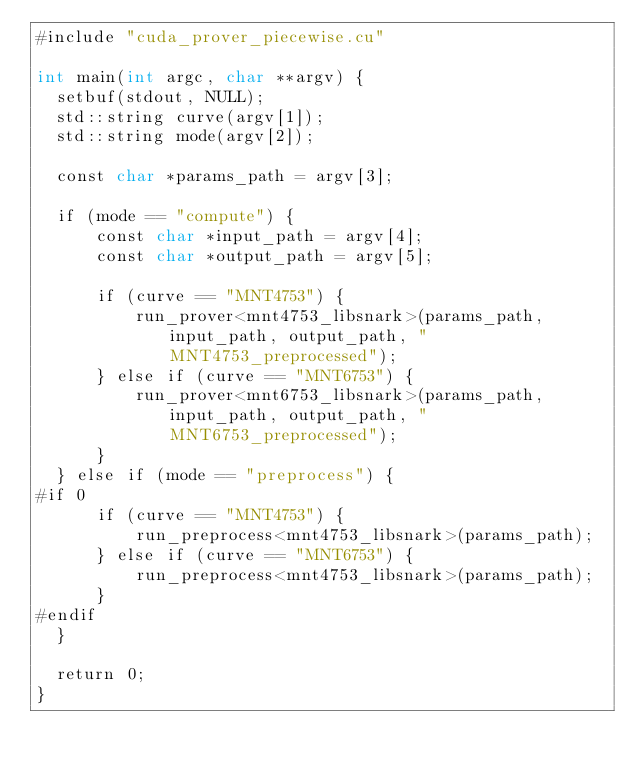Convert code to text. <code><loc_0><loc_0><loc_500><loc_500><_Cuda_>#include "cuda_prover_piecewise.cu"

int main(int argc, char **argv) {
  setbuf(stdout, NULL);
  std::string curve(argv[1]);
  std::string mode(argv[2]);

  const char *params_path = argv[3];

  if (mode == "compute") {
      const char *input_path = argv[4];
      const char *output_path = argv[5];

      if (curve == "MNT4753") {
          run_prover<mnt4753_libsnark>(params_path, input_path, output_path, "MNT4753_preprocessed");
      } else if (curve == "MNT6753") {
          run_prover<mnt6753_libsnark>(params_path, input_path, output_path, "MNT6753_preprocessed");
      }
  } else if (mode == "preprocess") {
#if 0
      if (curve == "MNT4753") {
          run_preprocess<mnt4753_libsnark>(params_path);
      } else if (curve == "MNT6753") {
          run_preprocess<mnt4753_libsnark>(params_path);
      }
#endif
  }

  return 0;
}
</code> 